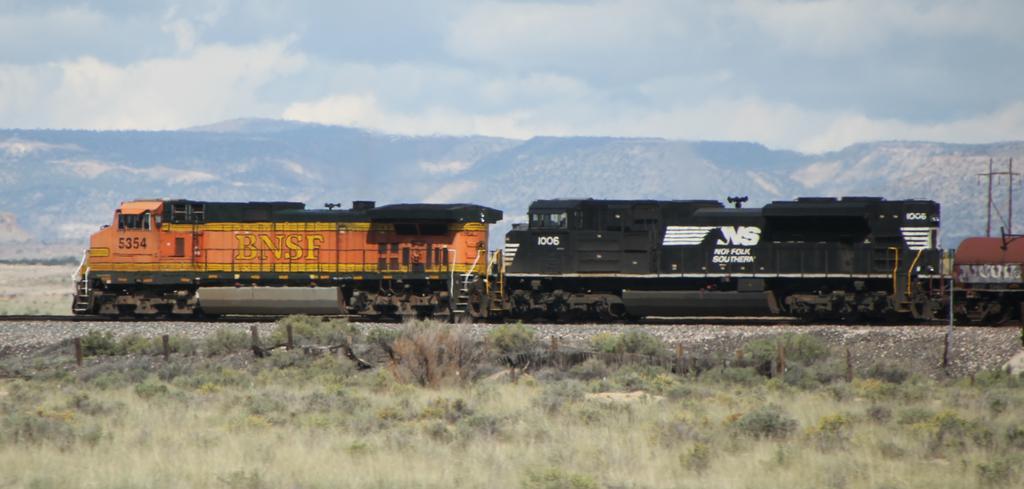Could you give a brief overview of what you see in this image? In this image we can see plants and grass on the ground, train on the railway track, stones and poles on the right side. In the background we can see mountains and clouds in the sky. 